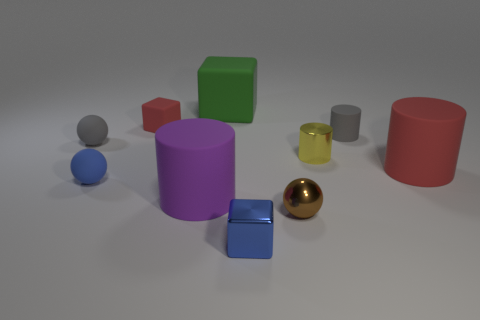There is a object that is the same color as the small metallic cube; what material is it?
Make the answer very short. Rubber. Are there any gray metal objects of the same shape as the small yellow metal object?
Provide a succinct answer. No. What number of green things are the same shape as the tiny brown thing?
Provide a short and direct response. 0. Is the tiny metallic cube the same color as the small metal ball?
Offer a terse response. No. Are there fewer tiny yellow things than large cyan cubes?
Keep it short and to the point. No. There is a small block behind the yellow metallic cylinder; what is its material?
Ensure brevity in your answer.  Rubber. There is a gray thing that is the same size as the gray sphere; what material is it?
Make the answer very short. Rubber. There is a small gray thing that is right of the object that is to the left of the blue ball left of the big green matte thing; what is its material?
Offer a very short reply. Rubber. There is a gray thing that is to the right of the purple cylinder; is its size the same as the small yellow cylinder?
Offer a terse response. Yes. Are there more small yellow things than matte cylinders?
Ensure brevity in your answer.  No. 